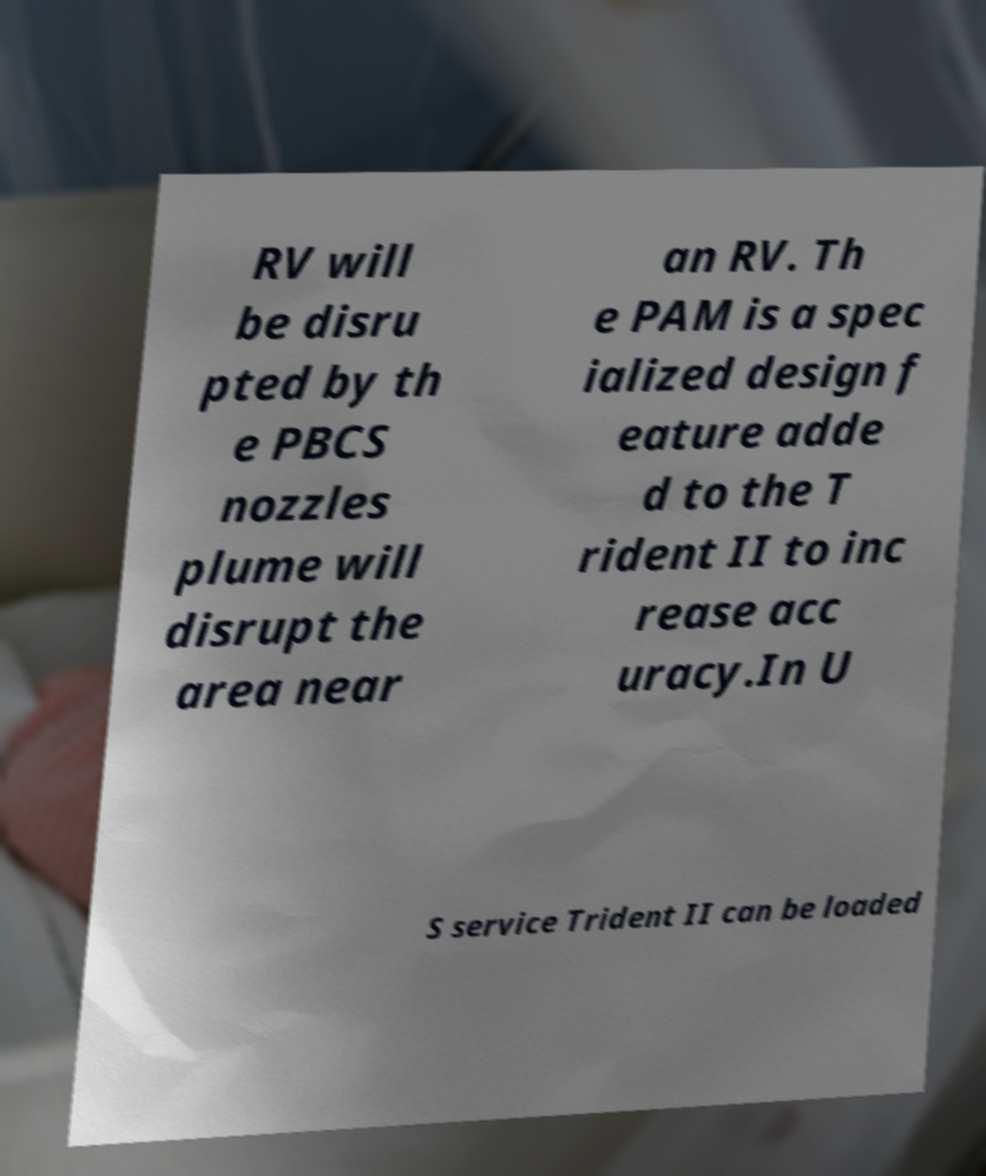Could you assist in decoding the text presented in this image and type it out clearly? RV will be disru pted by th e PBCS nozzles plume will disrupt the area near an RV. Th e PAM is a spec ialized design f eature adde d to the T rident II to inc rease acc uracy.In U S service Trident II can be loaded 